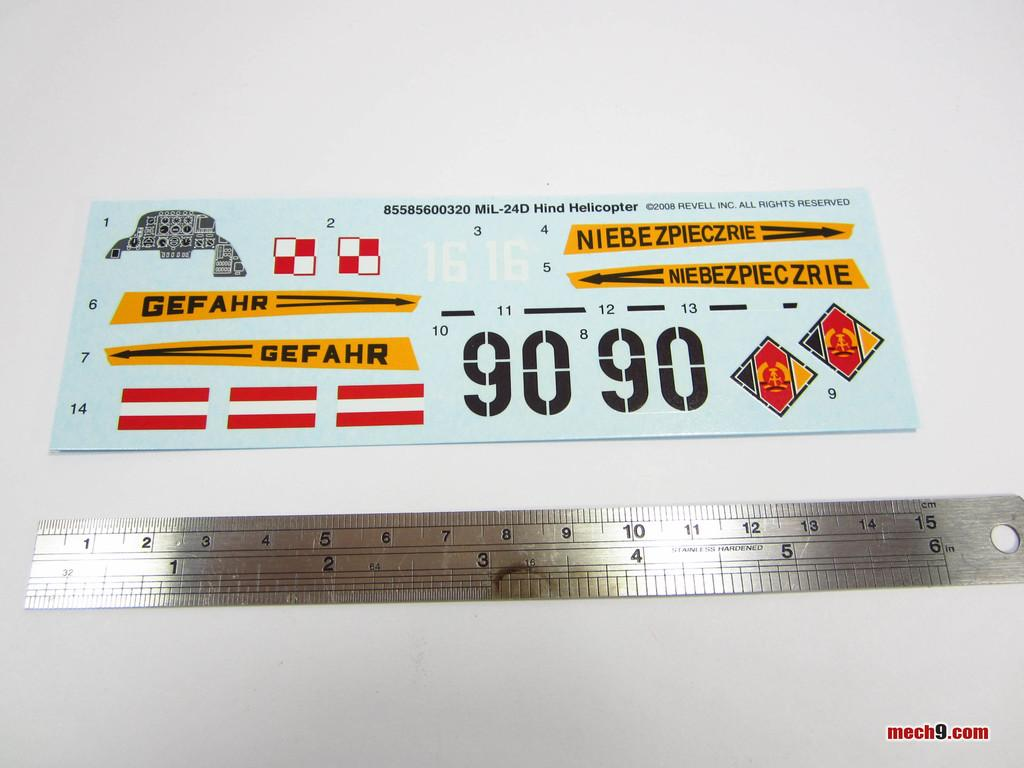<image>
Describe the image concisely. A metal ruler is lying next to a piece of paper with the number 9090 on it. 